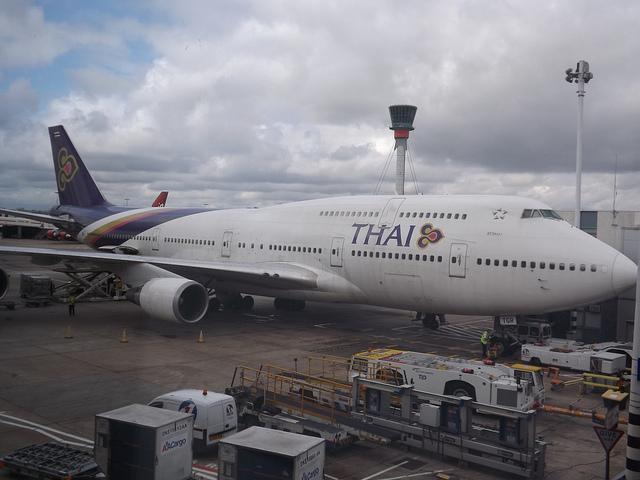How many chairs are pictured?
Give a very brief answer. 0. 